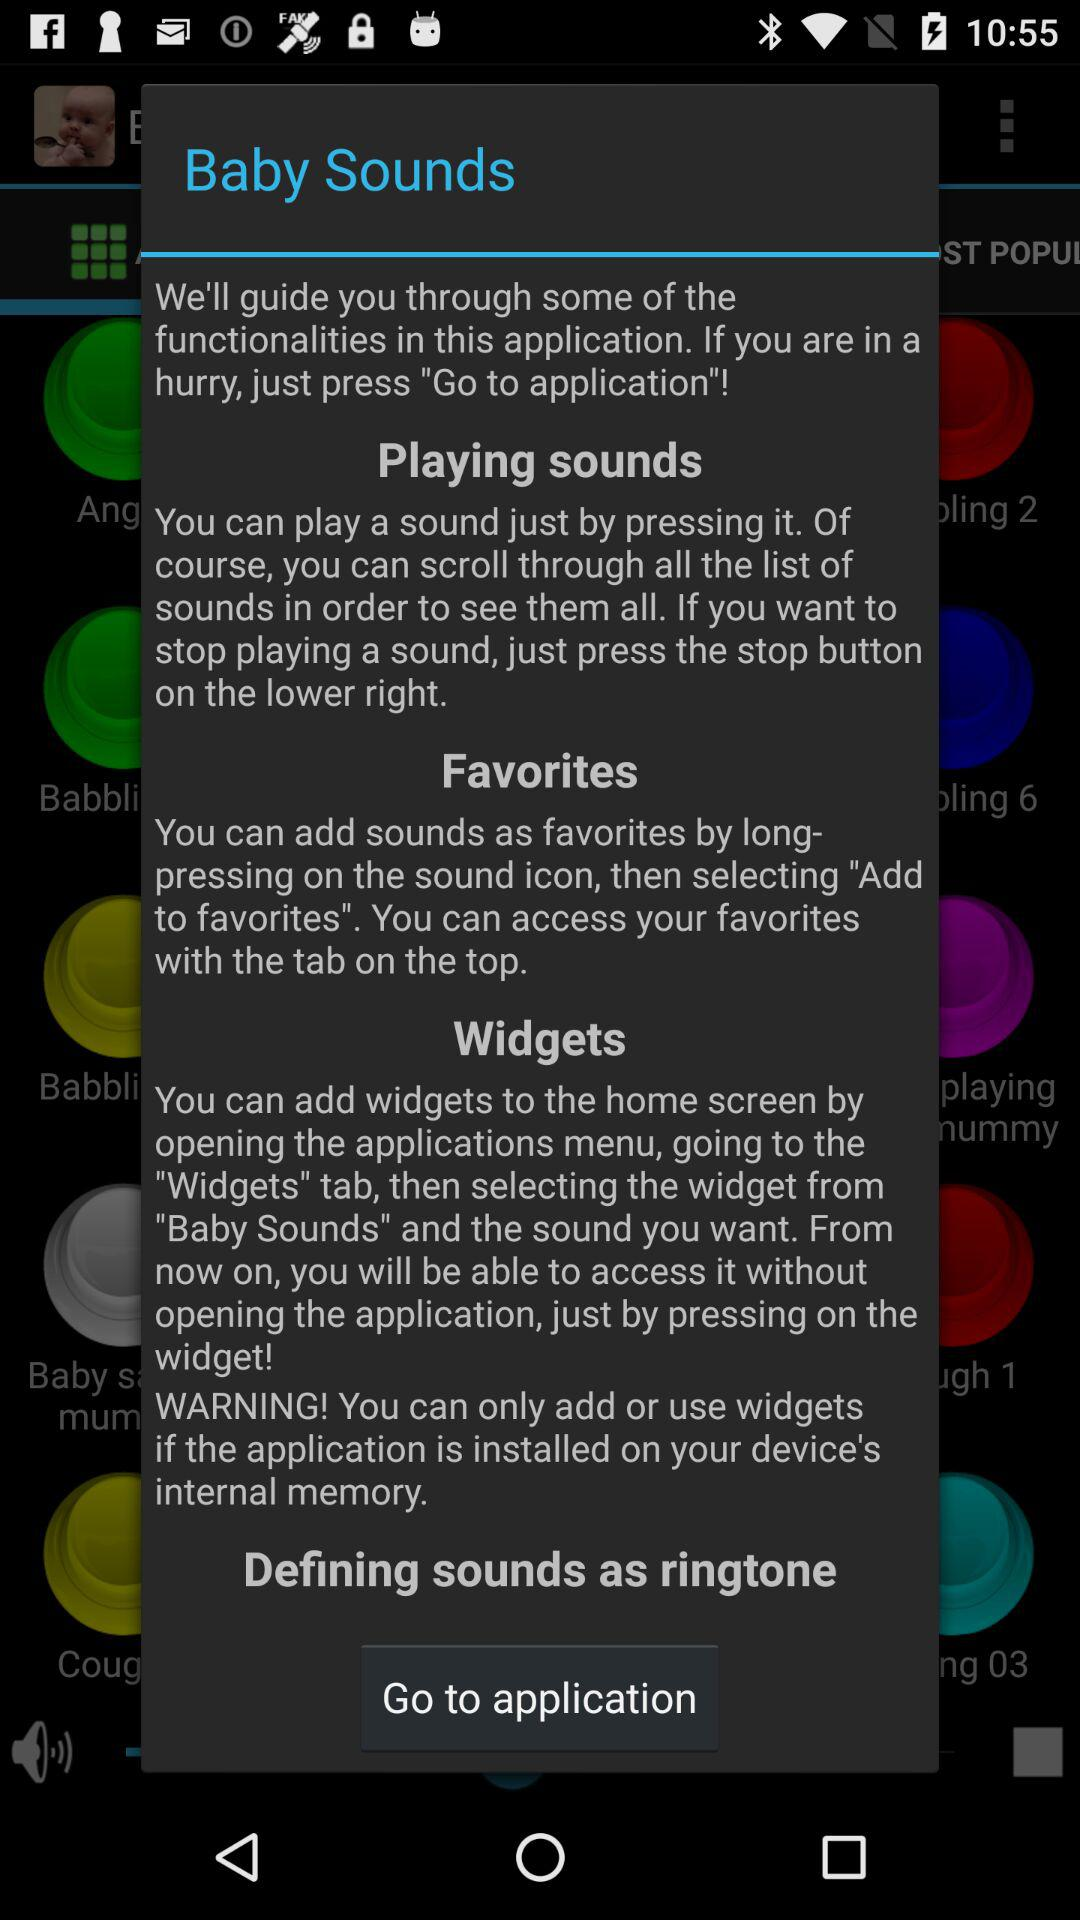What is the name of the application? The name of the application is "Baby Sounds". 